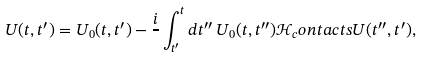Convert formula to latex. <formula><loc_0><loc_0><loc_500><loc_500>U ( t , t ^ { \prime } ) = U _ { 0 } ( t , t ^ { \prime } ) - \frac { i } { } \int _ { t ^ { \prime } } ^ { t } d t ^ { \prime \prime } \, U _ { 0 } ( t , t ^ { \prime \prime } ) \mathcal { H } _ { c } o n t a c t s U ( t ^ { \prime \prime } , t ^ { \prime } ) ,</formula> 